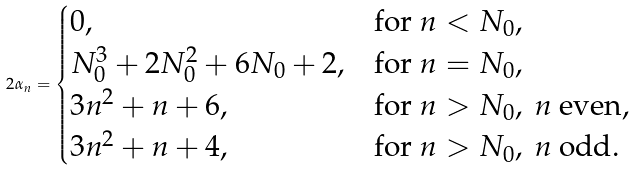<formula> <loc_0><loc_0><loc_500><loc_500>2 \alpha _ { n } = \begin{cases} 0 , & \text {for } n < N _ { 0 } , \\ N _ { 0 } ^ { 3 } + 2 N _ { 0 } ^ { 2 } + 6 N _ { 0 } + 2 , & \text {for } n = N _ { 0 } , \\ 3 n ^ { 2 } + n + 6 , & \text {for } n > N _ { 0 } , \ n \text { even} , \\ 3 n ^ { 2 } + n + 4 , & \text {for } n > N _ { 0 } , \ n \text { odd} . \end{cases}</formula> 